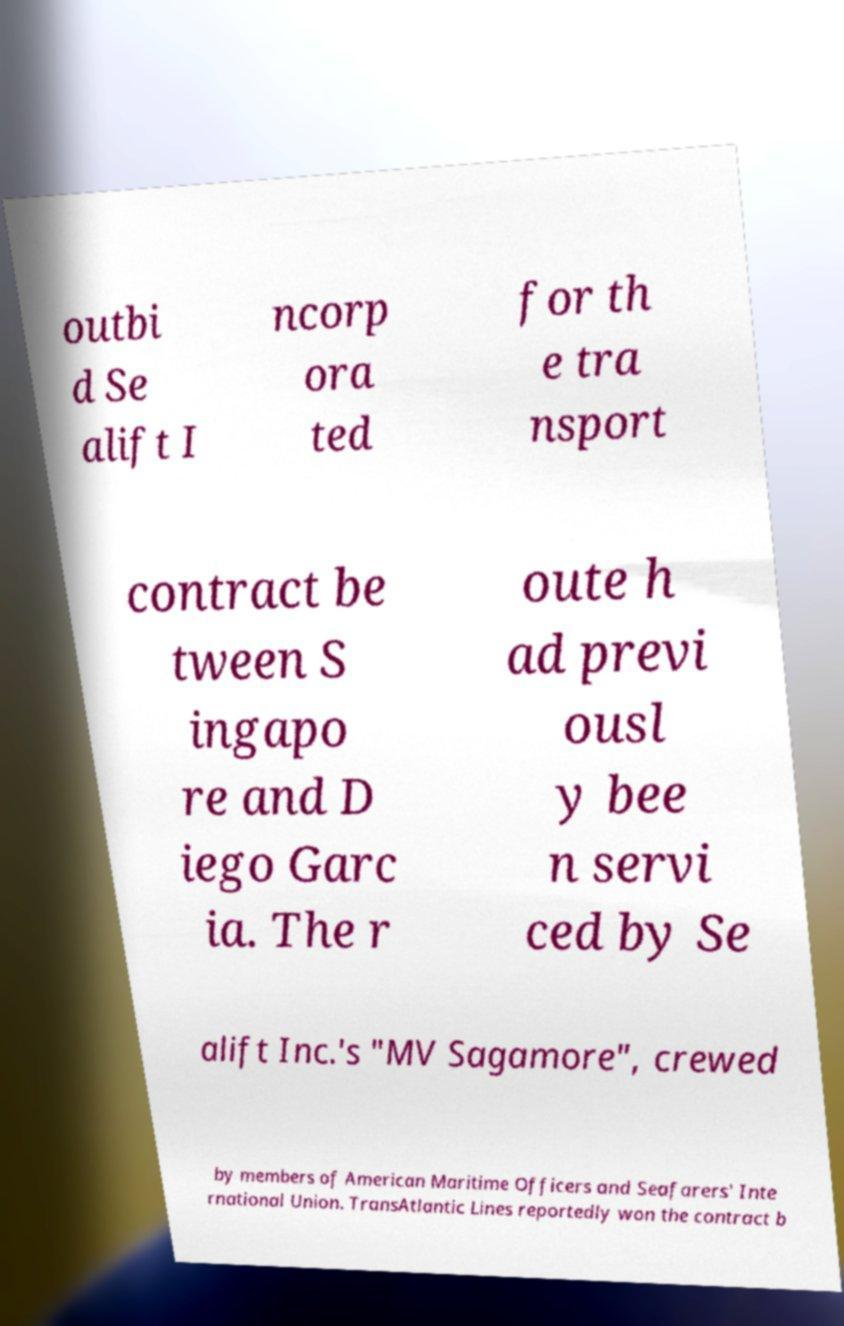There's text embedded in this image that I need extracted. Can you transcribe it verbatim? outbi d Se alift I ncorp ora ted for th e tra nsport contract be tween S ingapo re and D iego Garc ia. The r oute h ad previ ousl y bee n servi ced by Se alift Inc.'s "MV Sagamore", crewed by members of American Maritime Officers and Seafarers' Inte rnational Union. TransAtlantic Lines reportedly won the contract b 